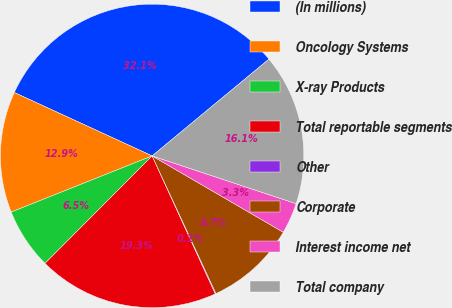Convert chart. <chart><loc_0><loc_0><loc_500><loc_500><pie_chart><fcel>(In millions)<fcel>Oncology Systems<fcel>X-ray Products<fcel>Total reportable segments<fcel>Other<fcel>Corporate<fcel>Interest income net<fcel>Total company<nl><fcel>32.13%<fcel>12.9%<fcel>6.49%<fcel>19.31%<fcel>0.08%<fcel>9.7%<fcel>3.29%<fcel>16.11%<nl></chart> 